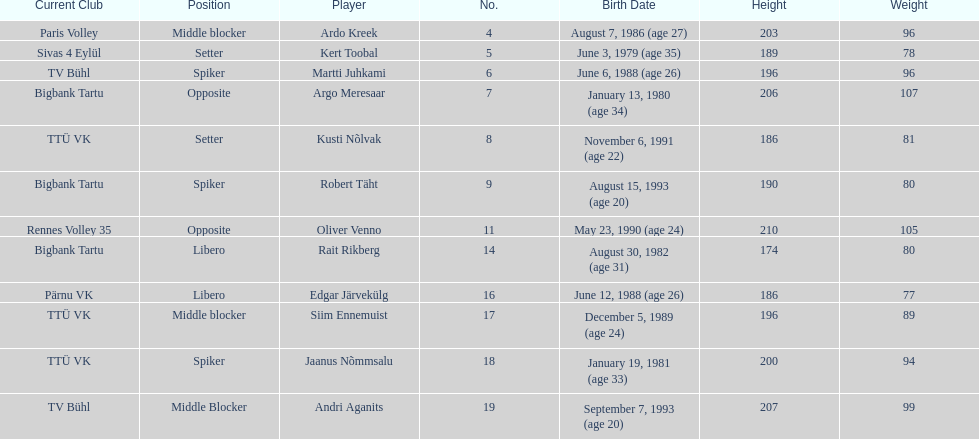Who is at least 25 years or older? Ardo Kreek, Kert Toobal, Martti Juhkami, Argo Meresaar, Rait Rikberg, Edgar Järvekülg, Jaanus Nõmmsalu. 